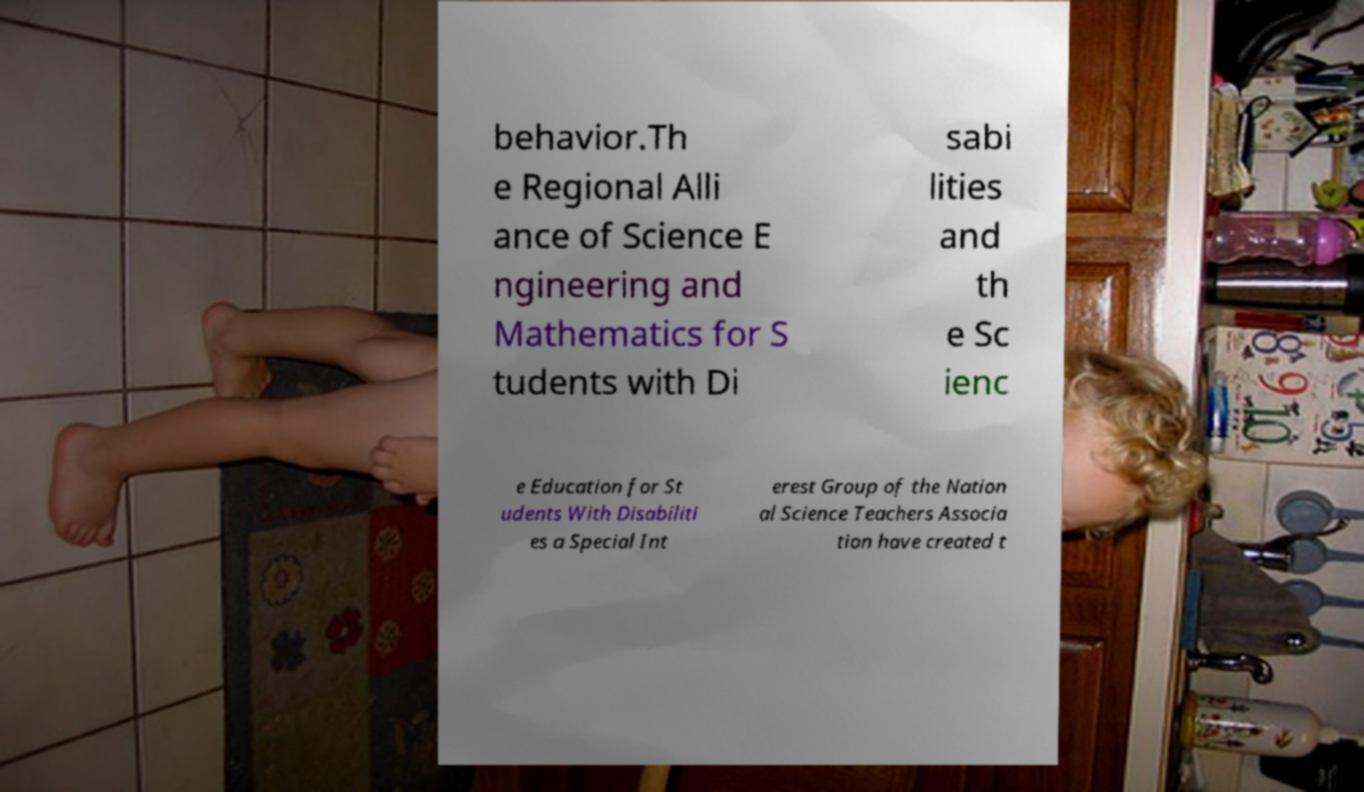Could you assist in decoding the text presented in this image and type it out clearly? behavior.Th e Regional Alli ance of Science E ngineering and Mathematics for S tudents with Di sabi lities and th e Sc ienc e Education for St udents With Disabiliti es a Special Int erest Group of the Nation al Science Teachers Associa tion have created t 